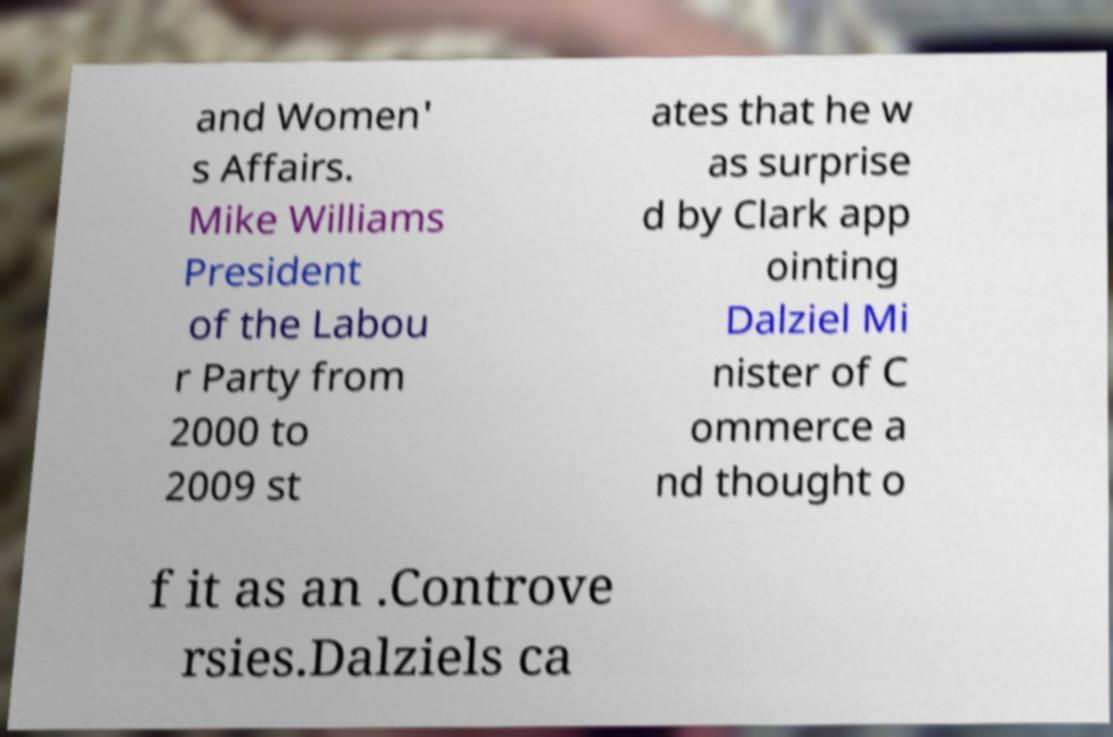Could you extract and type out the text from this image? and Women' s Affairs. Mike Williams President of the Labou r Party from 2000 to 2009 st ates that he w as surprise d by Clark app ointing Dalziel Mi nister of C ommerce a nd thought o f it as an .Controve rsies.Dalziels ca 